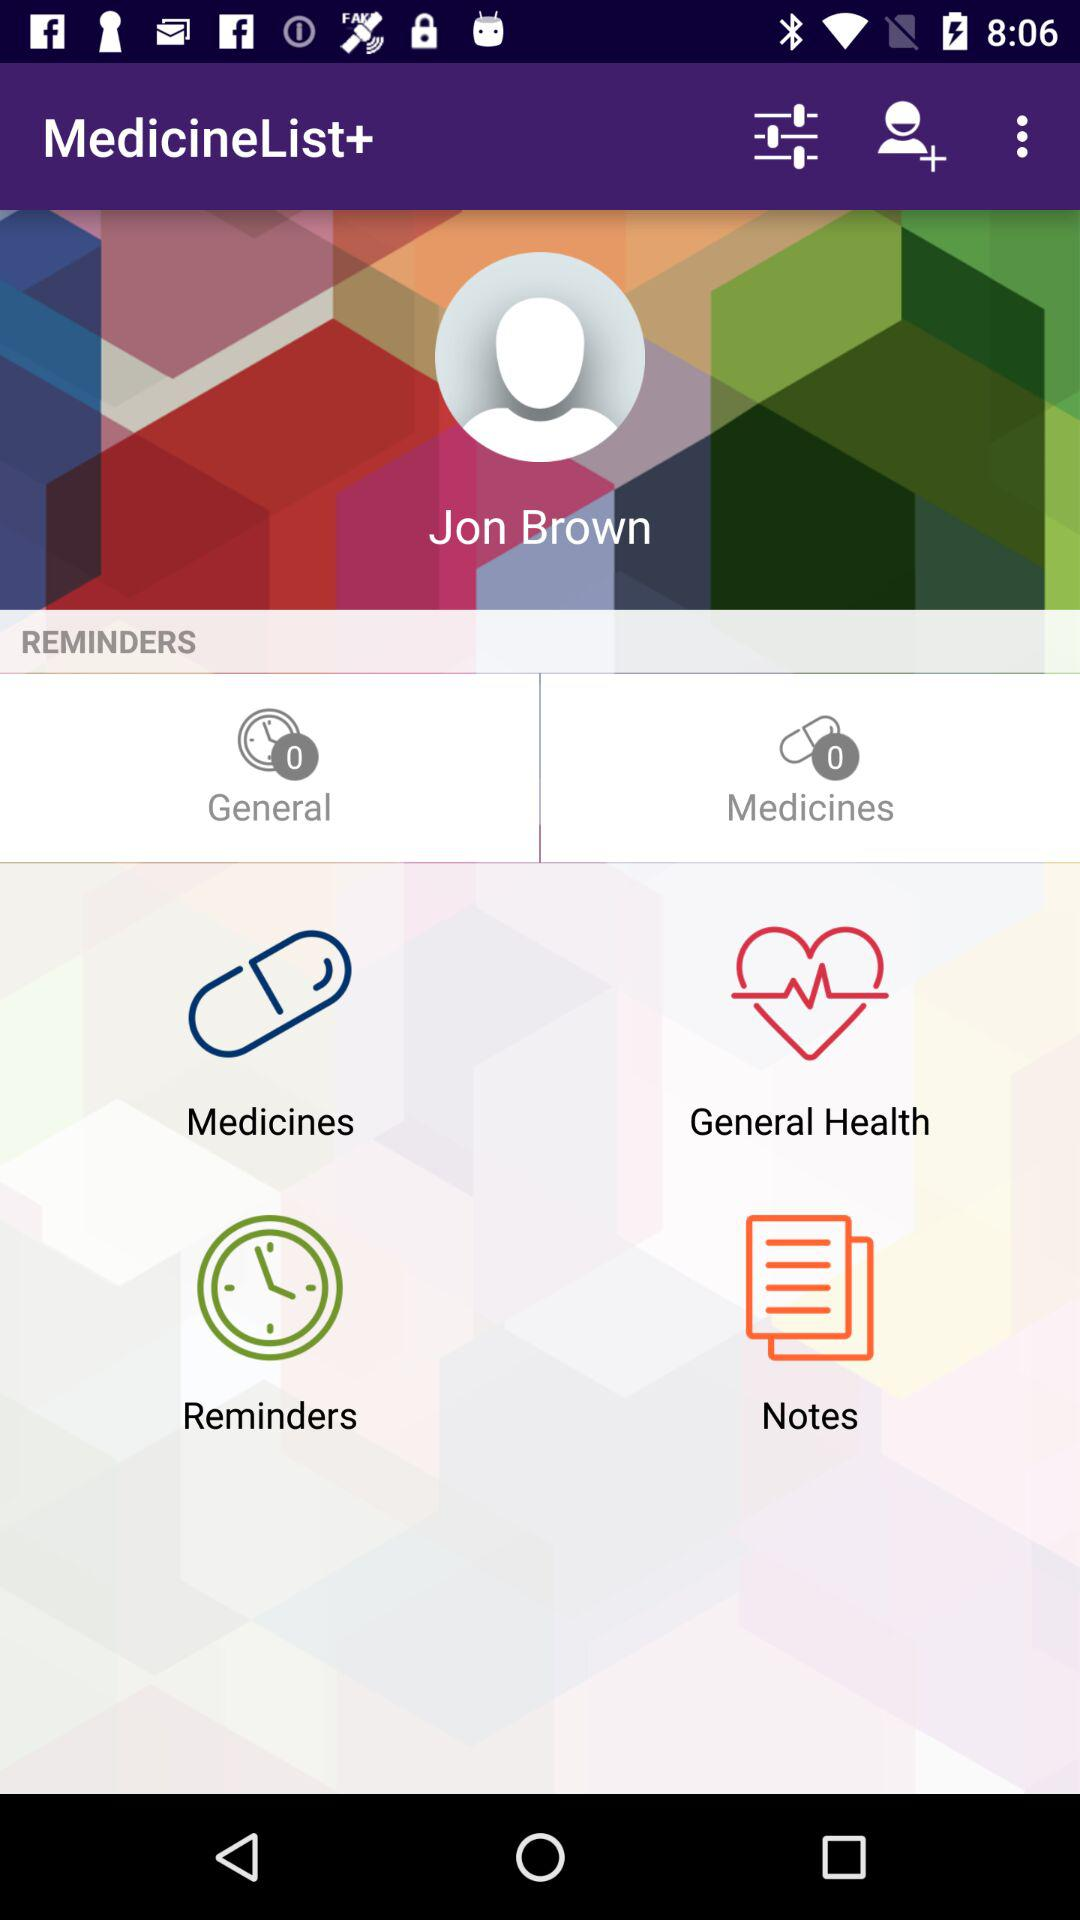What is the count for "General"? The count for "General" is 0. 